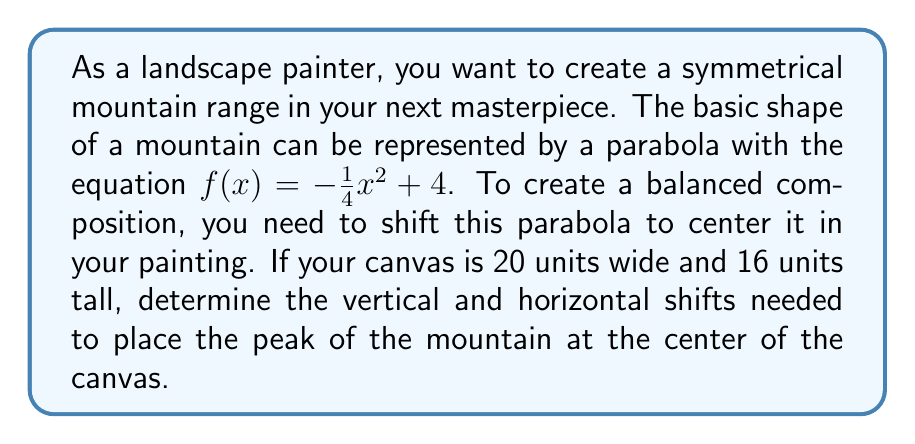Can you solve this math problem? Let's approach this step-by-step:

1) First, we need to understand the given parabola:
   $f(x) = -\frac{1}{4}x^2 + 4$
   This parabola opens downward and has its vertex at (0, 4).

2) The canvas dimensions are 20 units wide and 16 units tall. The center of the canvas would be at (10, 8).

3) To shift the parabola, we need to move it:
   - Horizontally by 10 units to the right
   - Vertically by 4 units up (from y = 4 to y = 8)

4) The general form of a vertically and horizontally shifted parabola is:
   $g(x) = a(x - h)^2 + k$
   where (h, k) is the new vertex of the parabola.

5) In our case, we want the new vertex to be (10, 8), so h = 10 and k = 8.

6) Substituting these values and keeping the same 'a' value (-1/4):
   $g(x) = -\frac{1}{4}(x - 10)^2 + 8$

7) Expanding this:
   $g(x) = -\frac{1}{4}(x^2 - 20x + 100) + 8$
   $g(x) = -\frac{1}{4}x^2 + 5x - 25 + 8$
   $g(x) = -\frac{1}{4}x^2 + 5x - 17$

This is the equation of the shifted parabola, representing our symmetrical mountain centered on the canvas.
Answer: The vertical shift is 4 units up, and the horizontal shift is 10 units right. The new equation of the parabola is $g(x) = -\frac{1}{4}x^2 + 5x - 17$. 